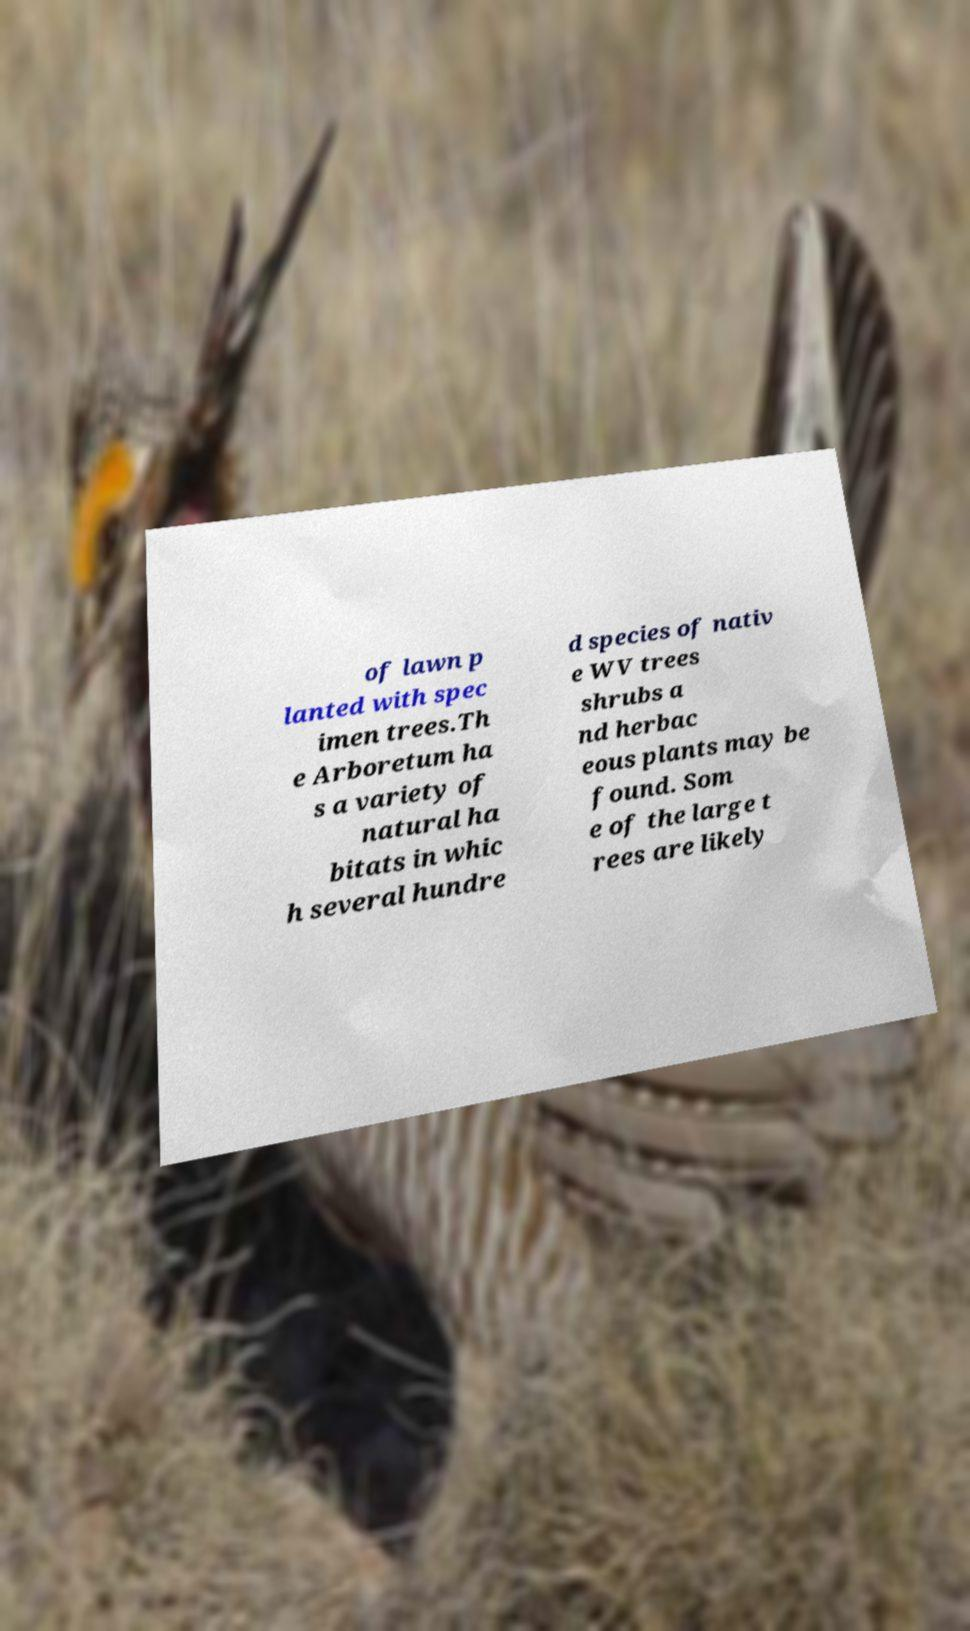I need the written content from this picture converted into text. Can you do that? of lawn p lanted with spec imen trees.Th e Arboretum ha s a variety of natural ha bitats in whic h several hundre d species of nativ e WV trees shrubs a nd herbac eous plants may be found. Som e of the large t rees are likely 